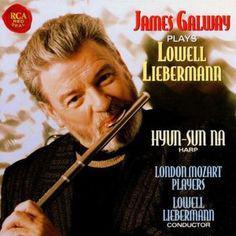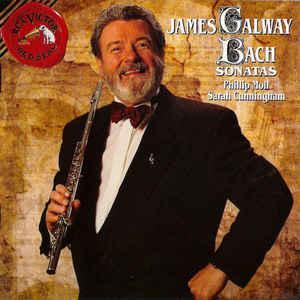The first image is the image on the left, the second image is the image on the right. For the images shown, is this caption "An image shows a man with a gray beard in a dark suit, holding a flute up to his ear with the hand on the left." true? Answer yes or no. Yes. The first image is the image on the left, the second image is the image on the right. Considering the images on both sides, is "At least one musician is playing the flute." valid? Answer yes or no. Yes. 